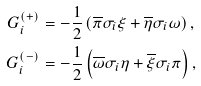<formula> <loc_0><loc_0><loc_500><loc_500>G _ { i } ^ { ( + ) } & = - \frac { 1 } { 2 } \left ( \overline { \pi } \sigma _ { i } \xi + \overline { \eta } \sigma _ { i } \omega \right ) , \\ G _ { i } ^ { ( - ) } & = - \frac { 1 } { 2 } \left ( \overline { \omega } \sigma _ { i } \eta + \overline { \xi } \sigma _ { i } \pi \right ) ,</formula> 